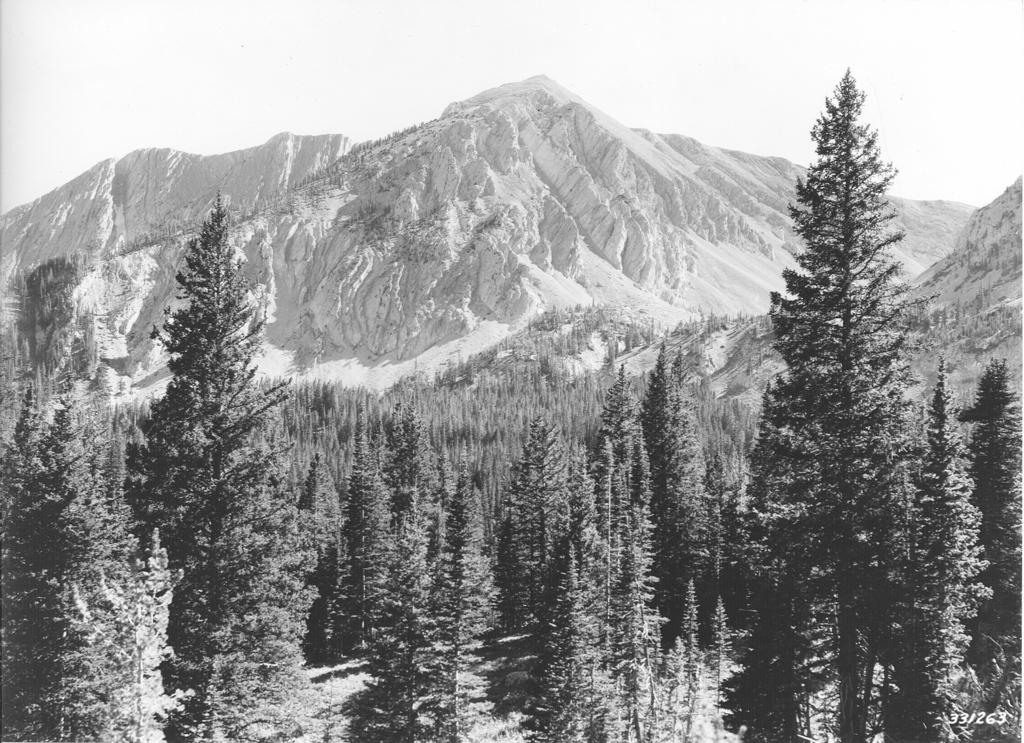What is the color scheme of the image? The image is black and white. What type of natural elements can be seen in the image? There are trees and mountains in the image. Where is the watermark located in the image? The watermark is on the bottom right side of the image. How many cows are visible in the image? There are no cows present in the image; it features trees and mountains in a black and white color scheme. What type of pin is holding the trees in place in the image? There is no pin holding the trees in place in the image; the trees are part of the natural landscape. 